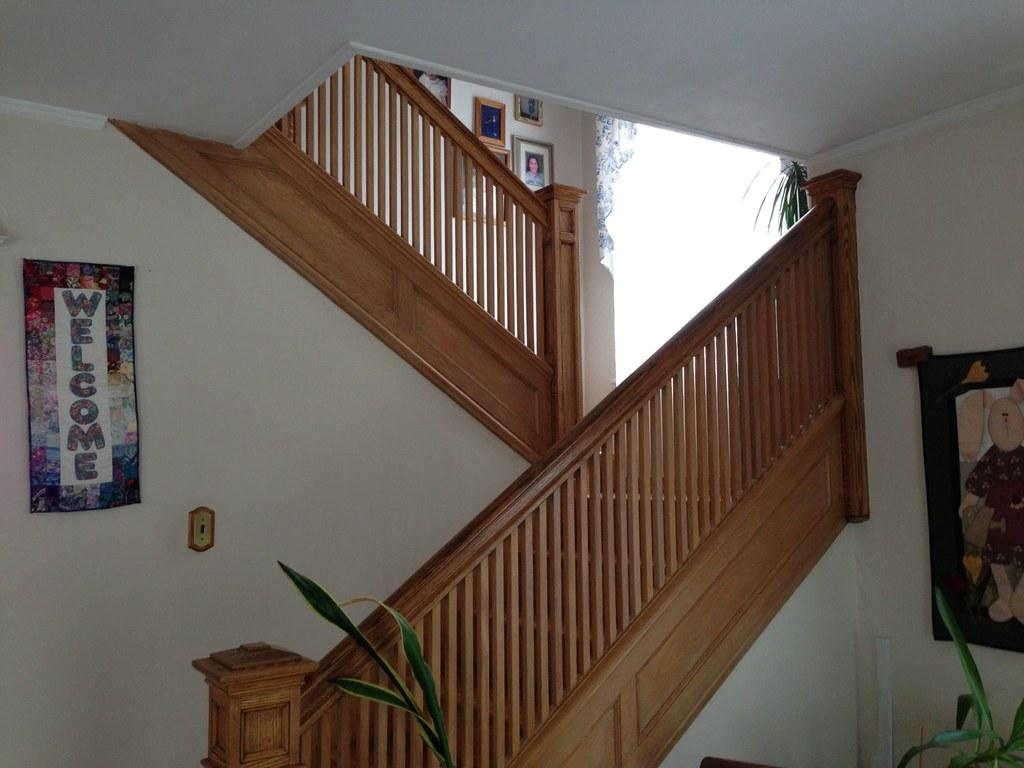What type of living organisms can be seen in the image? Plants are visible in the image. What architectural feature can be seen in the image? There are staircases in the image. What type of decorative items are present in the image? There are frames in the image. What type of wall decorations can be seen in the image? Posters are present on the walls in the image. Can you see any space-related objects in the image? There is no reference to space or any space-related objects in the image. Are there any waves visible in the image? There is no mention of waves or any water-related elements in the image. 